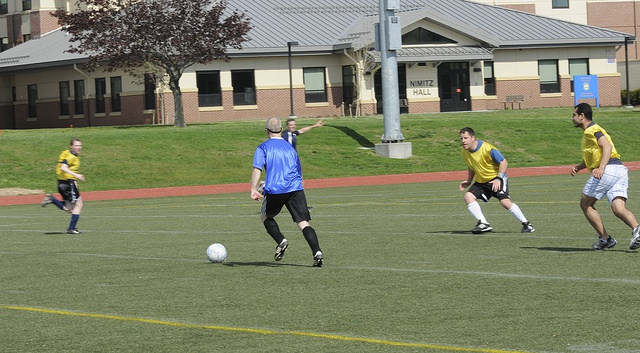Describe the objects in this image and their specific colors. I can see people in gray, black, lightblue, and blue tones, people in gray, lavender, tan, and black tones, people in gray, black, white, and olive tones, people in gray, black, navy, and darkgray tones, and people in gray, tan, and darkgray tones in this image. 